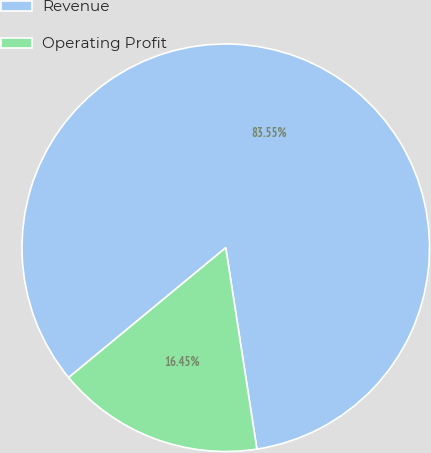Convert chart to OTSL. <chart><loc_0><loc_0><loc_500><loc_500><pie_chart><fcel>Revenue<fcel>Operating Profit<nl><fcel>83.55%<fcel>16.45%<nl></chart> 